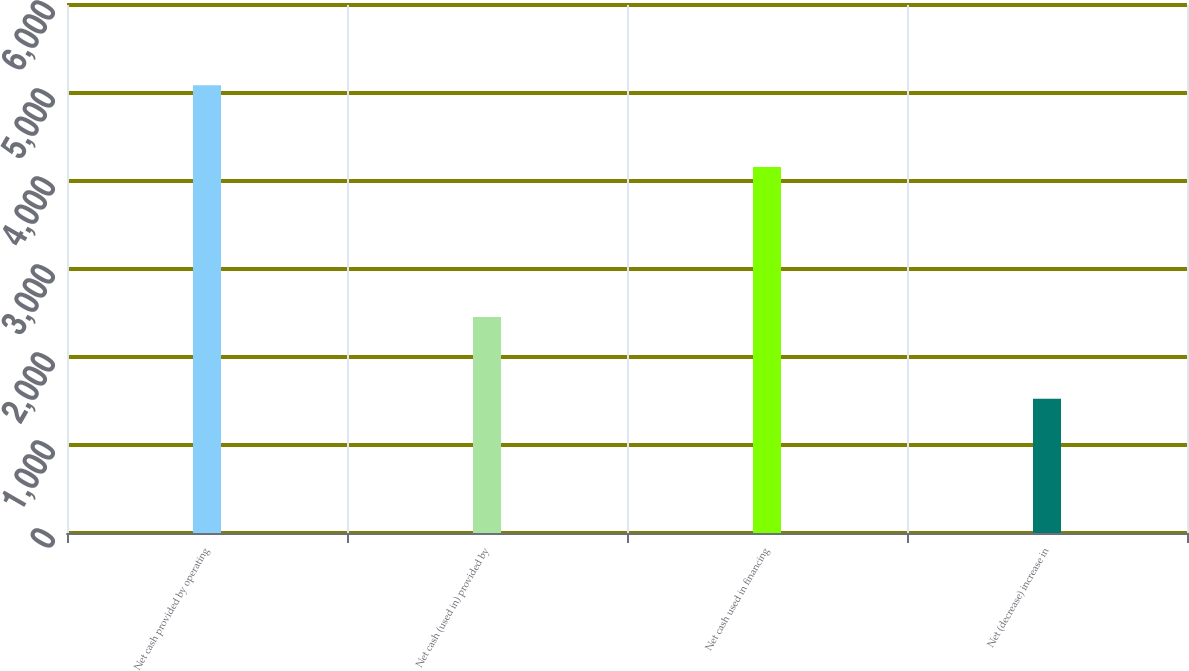Convert chart. <chart><loc_0><loc_0><loc_500><loc_500><bar_chart><fcel>Net cash provided by operating<fcel>Net cash (used in) provided by<fcel>Net cash used in financing<fcel>Net (decrease) increase in<nl><fcel>5088<fcel>2454<fcel>4159<fcel>1525<nl></chart> 